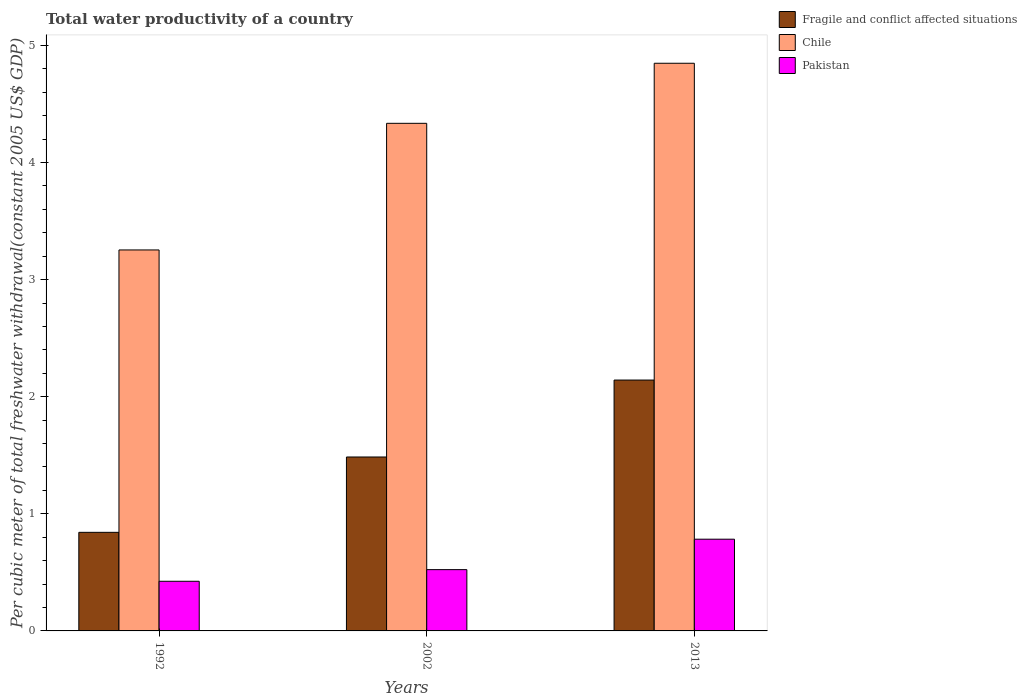Are the number of bars on each tick of the X-axis equal?
Your response must be concise. Yes. How many bars are there on the 2nd tick from the left?
Offer a very short reply. 3. In how many cases, is the number of bars for a given year not equal to the number of legend labels?
Provide a succinct answer. 0. What is the total water productivity in Pakistan in 1992?
Provide a short and direct response. 0.42. Across all years, what is the maximum total water productivity in Pakistan?
Offer a terse response. 0.78. Across all years, what is the minimum total water productivity in Fragile and conflict affected situations?
Your answer should be compact. 0.84. In which year was the total water productivity in Pakistan minimum?
Give a very brief answer. 1992. What is the total total water productivity in Fragile and conflict affected situations in the graph?
Give a very brief answer. 4.47. What is the difference between the total water productivity in Fragile and conflict affected situations in 2002 and that in 2013?
Ensure brevity in your answer.  -0.66. What is the difference between the total water productivity in Chile in 2002 and the total water productivity in Pakistan in 2013?
Offer a terse response. 3.55. What is the average total water productivity in Chile per year?
Your response must be concise. 4.15. In the year 2013, what is the difference between the total water productivity in Fragile and conflict affected situations and total water productivity in Chile?
Ensure brevity in your answer.  -2.71. What is the ratio of the total water productivity in Pakistan in 1992 to that in 2002?
Provide a succinct answer. 0.81. Is the total water productivity in Chile in 2002 less than that in 2013?
Provide a succinct answer. Yes. Is the difference between the total water productivity in Fragile and conflict affected situations in 1992 and 2002 greater than the difference between the total water productivity in Chile in 1992 and 2002?
Your response must be concise. Yes. What is the difference between the highest and the second highest total water productivity in Pakistan?
Provide a succinct answer. 0.26. What is the difference between the highest and the lowest total water productivity in Fragile and conflict affected situations?
Make the answer very short. 1.3. In how many years, is the total water productivity in Pakistan greater than the average total water productivity in Pakistan taken over all years?
Keep it short and to the point. 1. Is the sum of the total water productivity in Pakistan in 1992 and 2013 greater than the maximum total water productivity in Chile across all years?
Offer a terse response. No. What does the 1st bar from the left in 2002 represents?
Make the answer very short. Fragile and conflict affected situations. What does the 1st bar from the right in 2013 represents?
Your answer should be compact. Pakistan. What is the difference between two consecutive major ticks on the Y-axis?
Make the answer very short. 1. Are the values on the major ticks of Y-axis written in scientific E-notation?
Give a very brief answer. No. Does the graph contain any zero values?
Ensure brevity in your answer.  No. Does the graph contain grids?
Offer a terse response. No. What is the title of the graph?
Offer a very short reply. Total water productivity of a country. Does "Caribbean small states" appear as one of the legend labels in the graph?
Make the answer very short. No. What is the label or title of the X-axis?
Provide a succinct answer. Years. What is the label or title of the Y-axis?
Your answer should be very brief. Per cubic meter of total freshwater withdrawal(constant 2005 US$ GDP). What is the Per cubic meter of total freshwater withdrawal(constant 2005 US$ GDP) of Fragile and conflict affected situations in 1992?
Offer a very short reply. 0.84. What is the Per cubic meter of total freshwater withdrawal(constant 2005 US$ GDP) in Chile in 1992?
Give a very brief answer. 3.25. What is the Per cubic meter of total freshwater withdrawal(constant 2005 US$ GDP) in Pakistan in 1992?
Ensure brevity in your answer.  0.42. What is the Per cubic meter of total freshwater withdrawal(constant 2005 US$ GDP) in Fragile and conflict affected situations in 2002?
Offer a terse response. 1.49. What is the Per cubic meter of total freshwater withdrawal(constant 2005 US$ GDP) of Chile in 2002?
Offer a very short reply. 4.34. What is the Per cubic meter of total freshwater withdrawal(constant 2005 US$ GDP) of Pakistan in 2002?
Make the answer very short. 0.52. What is the Per cubic meter of total freshwater withdrawal(constant 2005 US$ GDP) in Fragile and conflict affected situations in 2013?
Your response must be concise. 2.14. What is the Per cubic meter of total freshwater withdrawal(constant 2005 US$ GDP) in Chile in 2013?
Make the answer very short. 4.85. What is the Per cubic meter of total freshwater withdrawal(constant 2005 US$ GDP) in Pakistan in 2013?
Provide a succinct answer. 0.78. Across all years, what is the maximum Per cubic meter of total freshwater withdrawal(constant 2005 US$ GDP) of Fragile and conflict affected situations?
Give a very brief answer. 2.14. Across all years, what is the maximum Per cubic meter of total freshwater withdrawal(constant 2005 US$ GDP) in Chile?
Give a very brief answer. 4.85. Across all years, what is the maximum Per cubic meter of total freshwater withdrawal(constant 2005 US$ GDP) in Pakistan?
Offer a terse response. 0.78. Across all years, what is the minimum Per cubic meter of total freshwater withdrawal(constant 2005 US$ GDP) of Fragile and conflict affected situations?
Ensure brevity in your answer.  0.84. Across all years, what is the minimum Per cubic meter of total freshwater withdrawal(constant 2005 US$ GDP) of Chile?
Keep it short and to the point. 3.25. Across all years, what is the minimum Per cubic meter of total freshwater withdrawal(constant 2005 US$ GDP) of Pakistan?
Give a very brief answer. 0.42. What is the total Per cubic meter of total freshwater withdrawal(constant 2005 US$ GDP) in Fragile and conflict affected situations in the graph?
Ensure brevity in your answer.  4.47. What is the total Per cubic meter of total freshwater withdrawal(constant 2005 US$ GDP) in Chile in the graph?
Your answer should be compact. 12.44. What is the total Per cubic meter of total freshwater withdrawal(constant 2005 US$ GDP) in Pakistan in the graph?
Ensure brevity in your answer.  1.73. What is the difference between the Per cubic meter of total freshwater withdrawal(constant 2005 US$ GDP) in Fragile and conflict affected situations in 1992 and that in 2002?
Make the answer very short. -0.64. What is the difference between the Per cubic meter of total freshwater withdrawal(constant 2005 US$ GDP) of Chile in 1992 and that in 2002?
Provide a succinct answer. -1.08. What is the difference between the Per cubic meter of total freshwater withdrawal(constant 2005 US$ GDP) of Pakistan in 1992 and that in 2002?
Your answer should be very brief. -0.1. What is the difference between the Per cubic meter of total freshwater withdrawal(constant 2005 US$ GDP) of Fragile and conflict affected situations in 1992 and that in 2013?
Provide a short and direct response. -1.3. What is the difference between the Per cubic meter of total freshwater withdrawal(constant 2005 US$ GDP) of Chile in 1992 and that in 2013?
Keep it short and to the point. -1.59. What is the difference between the Per cubic meter of total freshwater withdrawal(constant 2005 US$ GDP) of Pakistan in 1992 and that in 2013?
Provide a succinct answer. -0.36. What is the difference between the Per cubic meter of total freshwater withdrawal(constant 2005 US$ GDP) in Fragile and conflict affected situations in 2002 and that in 2013?
Give a very brief answer. -0.66. What is the difference between the Per cubic meter of total freshwater withdrawal(constant 2005 US$ GDP) of Chile in 2002 and that in 2013?
Keep it short and to the point. -0.51. What is the difference between the Per cubic meter of total freshwater withdrawal(constant 2005 US$ GDP) of Pakistan in 2002 and that in 2013?
Keep it short and to the point. -0.26. What is the difference between the Per cubic meter of total freshwater withdrawal(constant 2005 US$ GDP) in Fragile and conflict affected situations in 1992 and the Per cubic meter of total freshwater withdrawal(constant 2005 US$ GDP) in Chile in 2002?
Give a very brief answer. -3.49. What is the difference between the Per cubic meter of total freshwater withdrawal(constant 2005 US$ GDP) of Fragile and conflict affected situations in 1992 and the Per cubic meter of total freshwater withdrawal(constant 2005 US$ GDP) of Pakistan in 2002?
Offer a terse response. 0.32. What is the difference between the Per cubic meter of total freshwater withdrawal(constant 2005 US$ GDP) of Chile in 1992 and the Per cubic meter of total freshwater withdrawal(constant 2005 US$ GDP) of Pakistan in 2002?
Give a very brief answer. 2.73. What is the difference between the Per cubic meter of total freshwater withdrawal(constant 2005 US$ GDP) in Fragile and conflict affected situations in 1992 and the Per cubic meter of total freshwater withdrawal(constant 2005 US$ GDP) in Chile in 2013?
Provide a succinct answer. -4.01. What is the difference between the Per cubic meter of total freshwater withdrawal(constant 2005 US$ GDP) of Fragile and conflict affected situations in 1992 and the Per cubic meter of total freshwater withdrawal(constant 2005 US$ GDP) of Pakistan in 2013?
Provide a short and direct response. 0.06. What is the difference between the Per cubic meter of total freshwater withdrawal(constant 2005 US$ GDP) in Chile in 1992 and the Per cubic meter of total freshwater withdrawal(constant 2005 US$ GDP) in Pakistan in 2013?
Offer a very short reply. 2.47. What is the difference between the Per cubic meter of total freshwater withdrawal(constant 2005 US$ GDP) of Fragile and conflict affected situations in 2002 and the Per cubic meter of total freshwater withdrawal(constant 2005 US$ GDP) of Chile in 2013?
Offer a terse response. -3.36. What is the difference between the Per cubic meter of total freshwater withdrawal(constant 2005 US$ GDP) of Fragile and conflict affected situations in 2002 and the Per cubic meter of total freshwater withdrawal(constant 2005 US$ GDP) of Pakistan in 2013?
Your answer should be compact. 0.7. What is the difference between the Per cubic meter of total freshwater withdrawal(constant 2005 US$ GDP) of Chile in 2002 and the Per cubic meter of total freshwater withdrawal(constant 2005 US$ GDP) of Pakistan in 2013?
Give a very brief answer. 3.55. What is the average Per cubic meter of total freshwater withdrawal(constant 2005 US$ GDP) in Fragile and conflict affected situations per year?
Offer a very short reply. 1.49. What is the average Per cubic meter of total freshwater withdrawal(constant 2005 US$ GDP) in Chile per year?
Keep it short and to the point. 4.15. What is the average Per cubic meter of total freshwater withdrawal(constant 2005 US$ GDP) in Pakistan per year?
Your response must be concise. 0.58. In the year 1992, what is the difference between the Per cubic meter of total freshwater withdrawal(constant 2005 US$ GDP) in Fragile and conflict affected situations and Per cubic meter of total freshwater withdrawal(constant 2005 US$ GDP) in Chile?
Keep it short and to the point. -2.41. In the year 1992, what is the difference between the Per cubic meter of total freshwater withdrawal(constant 2005 US$ GDP) in Fragile and conflict affected situations and Per cubic meter of total freshwater withdrawal(constant 2005 US$ GDP) in Pakistan?
Your answer should be very brief. 0.42. In the year 1992, what is the difference between the Per cubic meter of total freshwater withdrawal(constant 2005 US$ GDP) of Chile and Per cubic meter of total freshwater withdrawal(constant 2005 US$ GDP) of Pakistan?
Provide a succinct answer. 2.83. In the year 2002, what is the difference between the Per cubic meter of total freshwater withdrawal(constant 2005 US$ GDP) of Fragile and conflict affected situations and Per cubic meter of total freshwater withdrawal(constant 2005 US$ GDP) of Chile?
Offer a very short reply. -2.85. In the year 2002, what is the difference between the Per cubic meter of total freshwater withdrawal(constant 2005 US$ GDP) in Fragile and conflict affected situations and Per cubic meter of total freshwater withdrawal(constant 2005 US$ GDP) in Pakistan?
Your response must be concise. 0.96. In the year 2002, what is the difference between the Per cubic meter of total freshwater withdrawal(constant 2005 US$ GDP) of Chile and Per cubic meter of total freshwater withdrawal(constant 2005 US$ GDP) of Pakistan?
Your answer should be compact. 3.81. In the year 2013, what is the difference between the Per cubic meter of total freshwater withdrawal(constant 2005 US$ GDP) in Fragile and conflict affected situations and Per cubic meter of total freshwater withdrawal(constant 2005 US$ GDP) in Chile?
Your answer should be compact. -2.71. In the year 2013, what is the difference between the Per cubic meter of total freshwater withdrawal(constant 2005 US$ GDP) in Fragile and conflict affected situations and Per cubic meter of total freshwater withdrawal(constant 2005 US$ GDP) in Pakistan?
Keep it short and to the point. 1.36. In the year 2013, what is the difference between the Per cubic meter of total freshwater withdrawal(constant 2005 US$ GDP) of Chile and Per cubic meter of total freshwater withdrawal(constant 2005 US$ GDP) of Pakistan?
Ensure brevity in your answer.  4.06. What is the ratio of the Per cubic meter of total freshwater withdrawal(constant 2005 US$ GDP) in Fragile and conflict affected situations in 1992 to that in 2002?
Offer a terse response. 0.57. What is the ratio of the Per cubic meter of total freshwater withdrawal(constant 2005 US$ GDP) of Chile in 1992 to that in 2002?
Offer a very short reply. 0.75. What is the ratio of the Per cubic meter of total freshwater withdrawal(constant 2005 US$ GDP) in Pakistan in 1992 to that in 2002?
Make the answer very short. 0.81. What is the ratio of the Per cubic meter of total freshwater withdrawal(constant 2005 US$ GDP) in Fragile and conflict affected situations in 1992 to that in 2013?
Offer a terse response. 0.39. What is the ratio of the Per cubic meter of total freshwater withdrawal(constant 2005 US$ GDP) in Chile in 1992 to that in 2013?
Your response must be concise. 0.67. What is the ratio of the Per cubic meter of total freshwater withdrawal(constant 2005 US$ GDP) of Pakistan in 1992 to that in 2013?
Offer a very short reply. 0.54. What is the ratio of the Per cubic meter of total freshwater withdrawal(constant 2005 US$ GDP) of Fragile and conflict affected situations in 2002 to that in 2013?
Provide a succinct answer. 0.69. What is the ratio of the Per cubic meter of total freshwater withdrawal(constant 2005 US$ GDP) in Chile in 2002 to that in 2013?
Provide a succinct answer. 0.89. What is the ratio of the Per cubic meter of total freshwater withdrawal(constant 2005 US$ GDP) in Pakistan in 2002 to that in 2013?
Keep it short and to the point. 0.67. What is the difference between the highest and the second highest Per cubic meter of total freshwater withdrawal(constant 2005 US$ GDP) in Fragile and conflict affected situations?
Provide a short and direct response. 0.66. What is the difference between the highest and the second highest Per cubic meter of total freshwater withdrawal(constant 2005 US$ GDP) in Chile?
Your answer should be very brief. 0.51. What is the difference between the highest and the second highest Per cubic meter of total freshwater withdrawal(constant 2005 US$ GDP) of Pakistan?
Provide a short and direct response. 0.26. What is the difference between the highest and the lowest Per cubic meter of total freshwater withdrawal(constant 2005 US$ GDP) of Fragile and conflict affected situations?
Offer a terse response. 1.3. What is the difference between the highest and the lowest Per cubic meter of total freshwater withdrawal(constant 2005 US$ GDP) in Chile?
Your answer should be compact. 1.59. What is the difference between the highest and the lowest Per cubic meter of total freshwater withdrawal(constant 2005 US$ GDP) in Pakistan?
Your response must be concise. 0.36. 